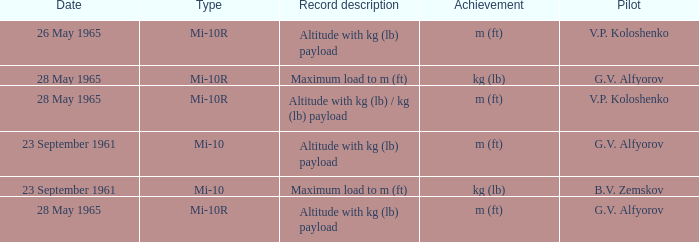Parse the table in full. {'header': ['Date', 'Type', 'Record description', 'Achievement', 'Pilot'], 'rows': [['26 May 1965', 'Mi-10R', 'Altitude with kg (lb) payload', 'm (ft)', 'V.P. Koloshenko'], ['28 May 1965', 'Mi-10R', 'Maximum load to m (ft)', 'kg (lb)', 'G.V. Alfyorov'], ['28 May 1965', 'Mi-10R', 'Altitude with kg (lb) / kg (lb) payload', 'm (ft)', 'V.P. Koloshenko'], ['23 September 1961', 'Mi-10', 'Altitude with kg (lb) payload', 'm (ft)', 'G.V. Alfyorov'], ['23 September 1961', 'Mi-10', 'Maximum load to m (ft)', 'kg (lb)', 'B.V. Zemskov'], ['28 May 1965', 'Mi-10R', 'Altitude with kg (lb) payload', 'm (ft)', 'G.V. Alfyorov']]} Record description of altitude with kg (lb) payload, and a Pilot of g.v. alfyorov had what type? Mi-10, Mi-10R. 